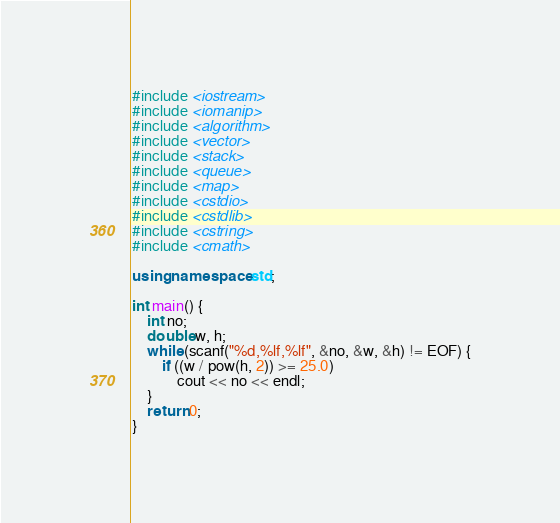Convert code to text. <code><loc_0><loc_0><loc_500><loc_500><_C++_>#include <iostream>
#include <iomanip>
#include <algorithm>
#include <vector>
#include <stack>
#include <queue>
#include <map>
#include <cstdio>
#include <cstdlib>
#include <cstring>
#include <cmath>

using namespace std;

int main() {
	int no;
	double w, h;
	while (scanf("%d,%lf,%lf", &no, &w, &h) != EOF) {
		if ((w / pow(h, 2)) >= 25.0)
			cout << no << endl;
	}
	return 0;
}</code> 